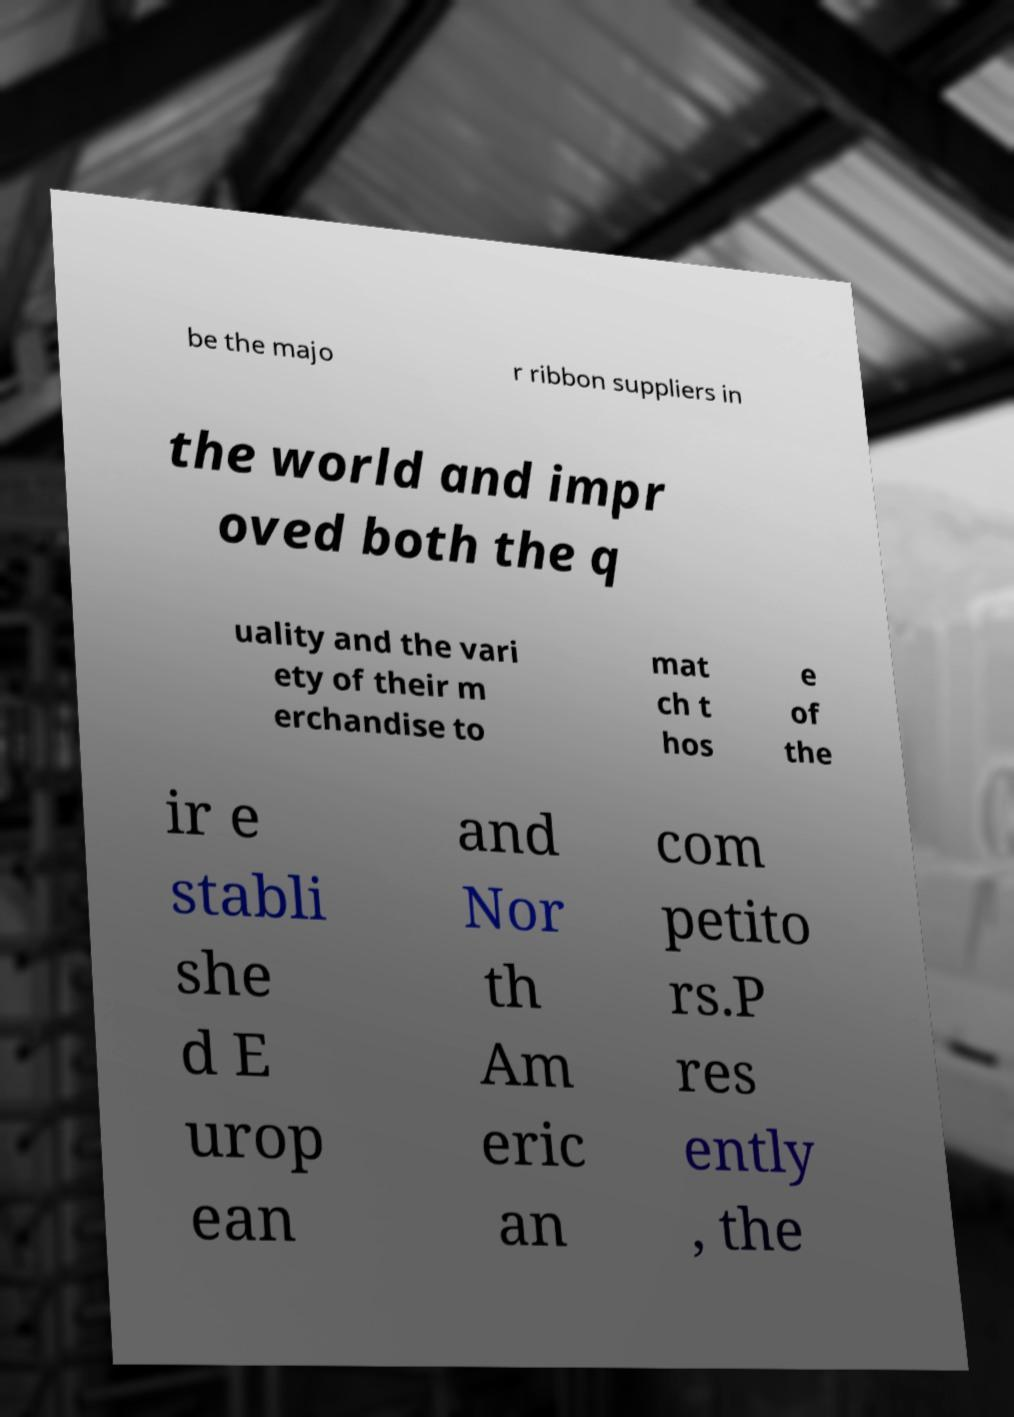I need the written content from this picture converted into text. Can you do that? be the majo r ribbon suppliers in the world and impr oved both the q uality and the vari ety of their m erchandise to mat ch t hos e of the ir e stabli she d E urop ean and Nor th Am eric an com petito rs.P res ently , the 